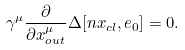Convert formula to latex. <formula><loc_0><loc_0><loc_500><loc_500>\gamma ^ { \mu } \frac { \partial } { \partial { x } _ { o u t } ^ { \mu } } \Delta [ n x _ { c l } , e _ { 0 } ] = 0 .</formula> 